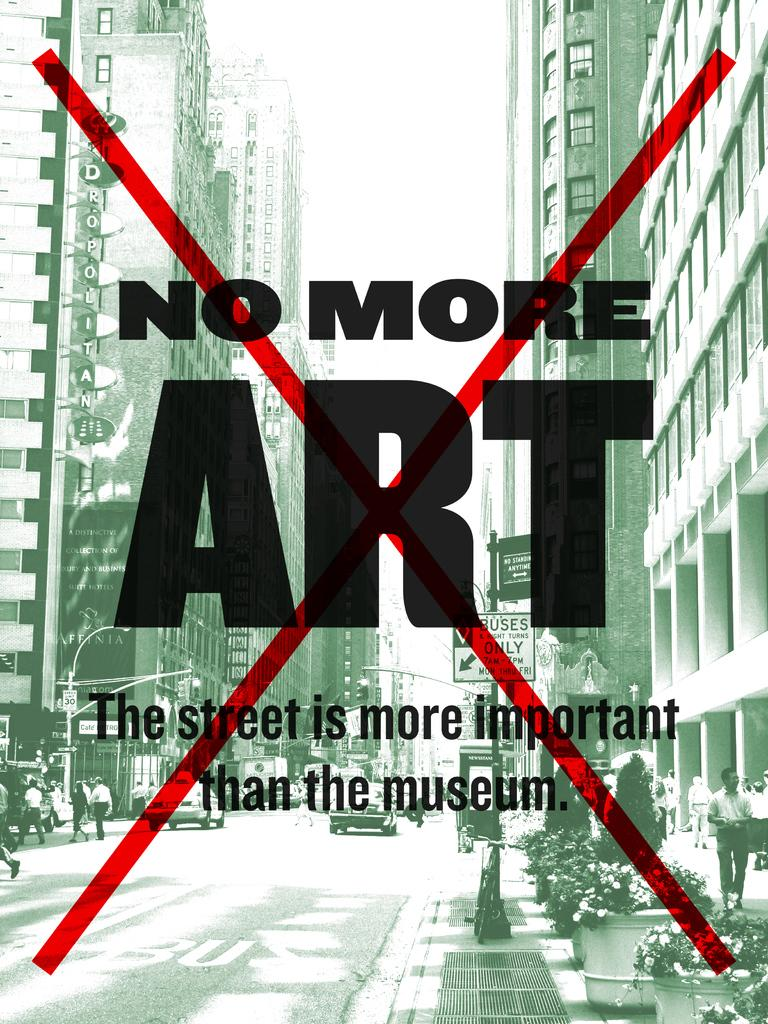<image>
Give a short and clear explanation of the subsequent image. a paper that says 'no more art' on it 